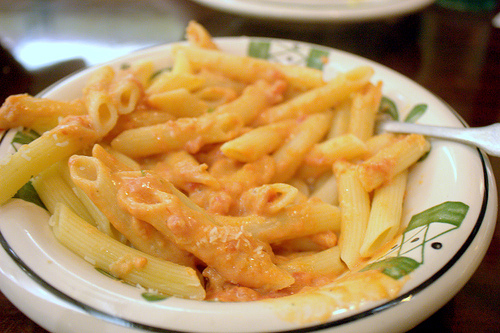<image>
Is the plate in the cheese? No. The plate is not contained within the cheese. These objects have a different spatial relationship. 